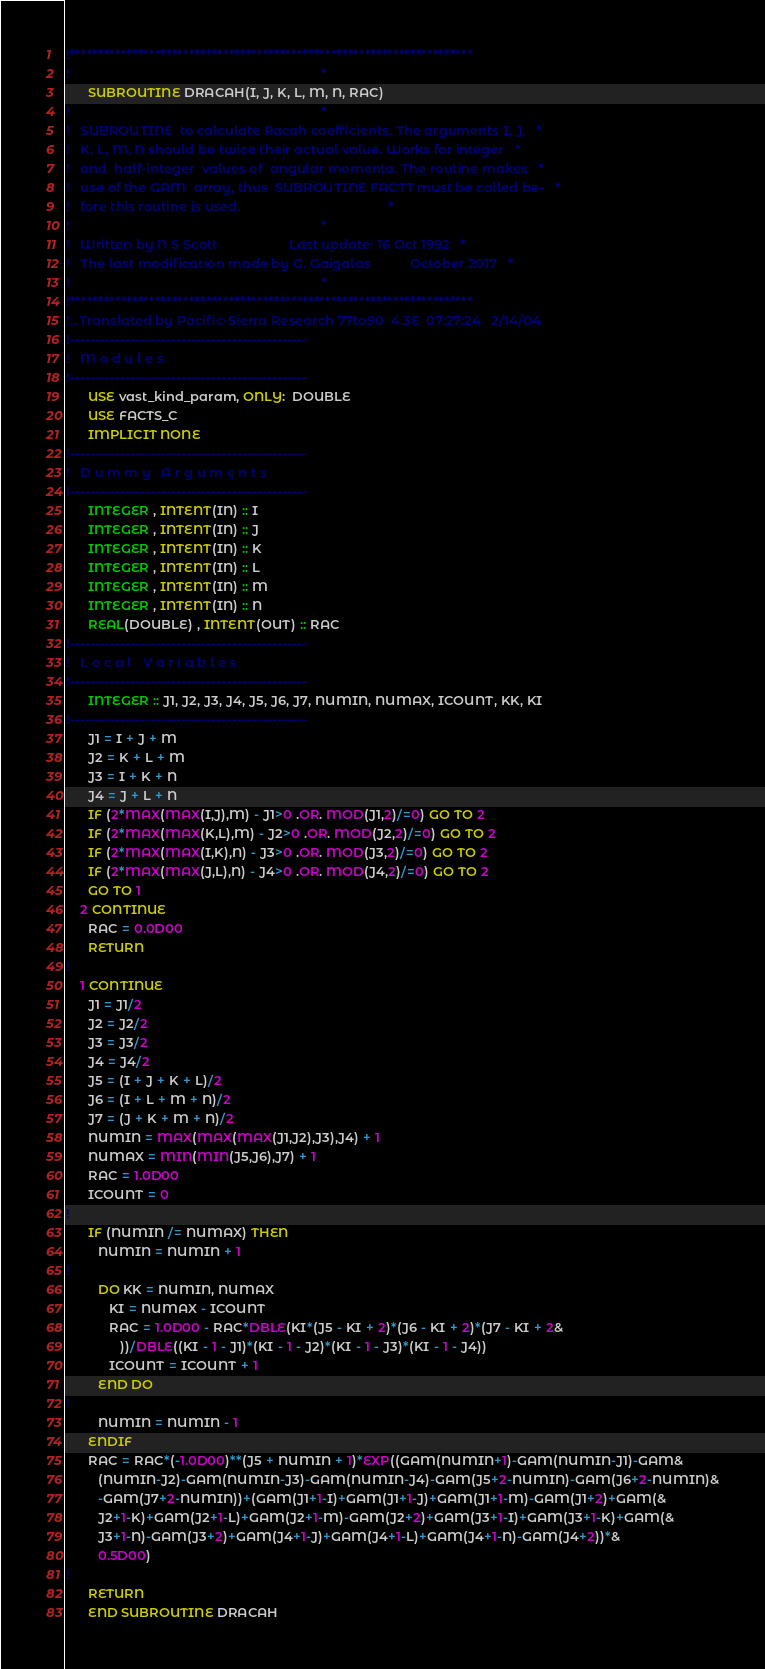<code> <loc_0><loc_0><loc_500><loc_500><_FORTRAN_>!***********************************************************************
!                                                                      *
      SUBROUTINE DRACAH(I, J, K, L, M, N, RAC)
!                                                                      *
!   SUBROUTINE  to calculate Racah coefficients. The arguments I, J,   *
!   K, L, M, N should be twice their actual value. Works for integer   *
!   and  half-integer  values of  angular momenta. The routine makes   *
!   use of the GAM  array, thus  SUBROUTINE FACTT must be called be-   *
!   fore this routine is used.                                         *
!                                                                      *
!   Written by N S Scott                    Last update: 16 Oct 1992   *
!   The last modification made by G. Gaigalas           October 2017   *
!                                                                      *
!***********************************************************************
!...Translated by Pacific-Sierra Research 77to90  4.3E  07:27:24   2/14/04
!-----------------------------------------------
!   M o d u l e s
!-----------------------------------------------
      USE vast_kind_param, ONLY:  DOUBLE
      USE FACTS_C
      IMPLICIT NONE
!-----------------------------------------------
!   D u m m y   A r g u m e n t s
!-----------------------------------------------
      INTEGER , INTENT(IN) :: I
      INTEGER , INTENT(IN) :: J
      INTEGER , INTENT(IN) :: K
      INTEGER , INTENT(IN) :: L
      INTEGER , INTENT(IN) :: M
      INTEGER , INTENT(IN) :: N
      REAL(DOUBLE) , INTENT(OUT) :: RAC
!-----------------------------------------------
!   L o c a l   V a r i a b l e s
!-----------------------------------------------
      INTEGER :: J1, J2, J3, J4, J5, J6, J7, NUMIN, NUMAX, ICOUNT, KK, KI
!-----------------------------------------------
      J1 = I + J + M
      J2 = K + L + M
      J3 = I + K + N
      J4 = J + L + N
      IF (2*MAX(MAX(I,J),M) - J1>0 .OR. MOD(J1,2)/=0) GO TO 2
      IF (2*MAX(MAX(K,L),M) - J2>0 .OR. MOD(J2,2)/=0) GO TO 2
      IF (2*MAX(MAX(I,K),N) - J3>0 .OR. MOD(J3,2)/=0) GO TO 2
      IF (2*MAX(MAX(J,L),N) - J4>0 .OR. MOD(J4,2)/=0) GO TO 2
      GO TO 1
    2 CONTINUE
      RAC = 0.0D00
      RETURN
!
    1 CONTINUE
      J1 = J1/2
      J2 = J2/2
      J3 = J3/2
      J4 = J4/2
      J5 = (I + J + K + L)/2
      J6 = (I + L + M + N)/2
      J7 = (J + K + M + N)/2
      NUMIN = MAX(MAX(MAX(J1,J2),J3),J4) + 1
      NUMAX = MIN(MIN(J5,J6),J7) + 1
      RAC = 1.0D00
      ICOUNT = 0
!
      IF (NUMIN /= NUMAX) THEN
         NUMIN = NUMIN + 1
!
         DO KK = NUMIN, NUMAX
            KI = NUMAX - ICOUNT
            RAC = 1.0D00 - RAC*DBLE(KI*(J5 - KI + 2)*(J6 - KI + 2)*(J7 - KI + 2&
               ))/DBLE((KI - 1 - J1)*(KI - 1 - J2)*(KI - 1 - J3)*(KI - 1 - J4))
            ICOUNT = ICOUNT + 1
         END DO
!
         NUMIN = NUMIN - 1
      ENDIF
      RAC = RAC*(-1.0D00)**(J5 + NUMIN + 1)*EXP((GAM(NUMIN+1)-GAM(NUMIN-J1)-GAM&
         (NUMIN-J2)-GAM(NUMIN-J3)-GAM(NUMIN-J4)-GAM(J5+2-NUMIN)-GAM(J6+2-NUMIN)&
         -GAM(J7+2-NUMIN))+(GAM(J1+1-I)+GAM(J1+1-J)+GAM(J1+1-M)-GAM(J1+2)+GAM(&
         J2+1-K)+GAM(J2+1-L)+GAM(J2+1-M)-GAM(J2+2)+GAM(J3+1-I)+GAM(J3+1-K)+GAM(&
         J3+1-N)-GAM(J3+2)+GAM(J4+1-J)+GAM(J4+1-L)+GAM(J4+1-N)-GAM(J4+2))*&
         0.5D00)
!
      RETURN
      END SUBROUTINE DRACAH
</code> 